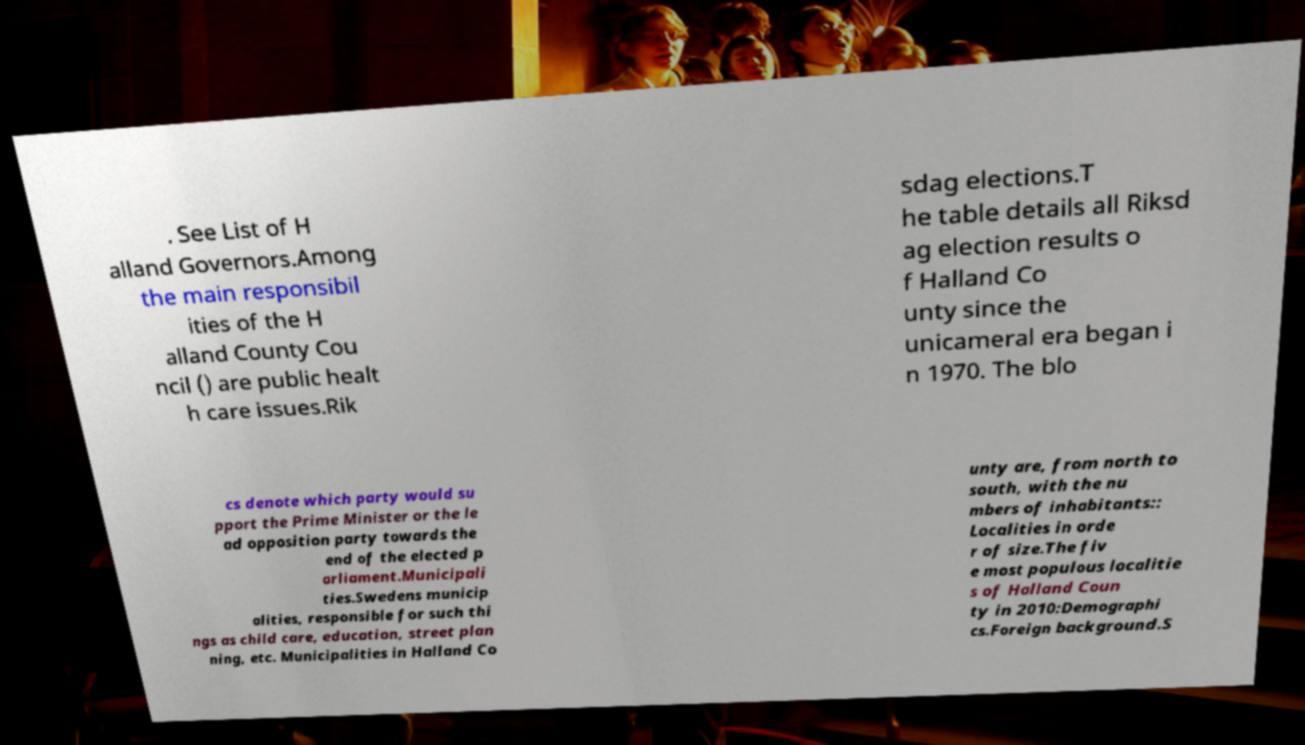Could you assist in decoding the text presented in this image and type it out clearly? . See List of H alland Governors.Among the main responsibil ities of the H alland County Cou ncil () are public healt h care issues.Rik sdag elections.T he table details all Riksd ag election results o f Halland Co unty since the unicameral era began i n 1970. The blo cs denote which party would su pport the Prime Minister or the le ad opposition party towards the end of the elected p arliament.Municipali ties.Swedens municip alities, responsible for such thi ngs as child care, education, street plan ning, etc. Municipalities in Halland Co unty are, from north to south, with the nu mbers of inhabitants:: Localities in orde r of size.The fiv e most populous localitie s of Halland Coun ty in 2010:Demographi cs.Foreign background.S 